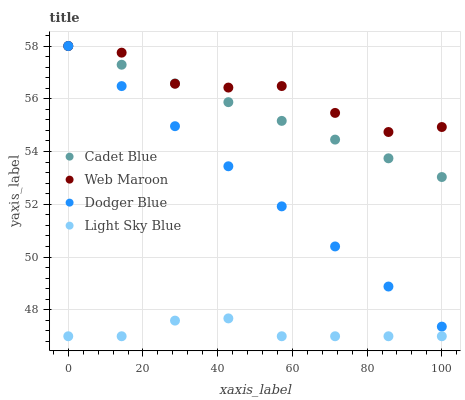Does Light Sky Blue have the minimum area under the curve?
Answer yes or no. Yes. Does Web Maroon have the maximum area under the curve?
Answer yes or no. Yes. Does Cadet Blue have the minimum area under the curve?
Answer yes or no. No. Does Cadet Blue have the maximum area under the curve?
Answer yes or no. No. Is Cadet Blue the smoothest?
Answer yes or no. Yes. Is Web Maroon the roughest?
Answer yes or no. Yes. Is Web Maroon the smoothest?
Answer yes or no. No. Is Cadet Blue the roughest?
Answer yes or no. No. Does Light Sky Blue have the lowest value?
Answer yes or no. Yes. Does Cadet Blue have the lowest value?
Answer yes or no. No. Does Web Maroon have the highest value?
Answer yes or no. Yes. Does Light Sky Blue have the highest value?
Answer yes or no. No. Is Light Sky Blue less than Dodger Blue?
Answer yes or no. Yes. Is Dodger Blue greater than Light Sky Blue?
Answer yes or no. Yes. Does Web Maroon intersect Cadet Blue?
Answer yes or no. Yes. Is Web Maroon less than Cadet Blue?
Answer yes or no. No. Is Web Maroon greater than Cadet Blue?
Answer yes or no. No. Does Light Sky Blue intersect Dodger Blue?
Answer yes or no. No. 